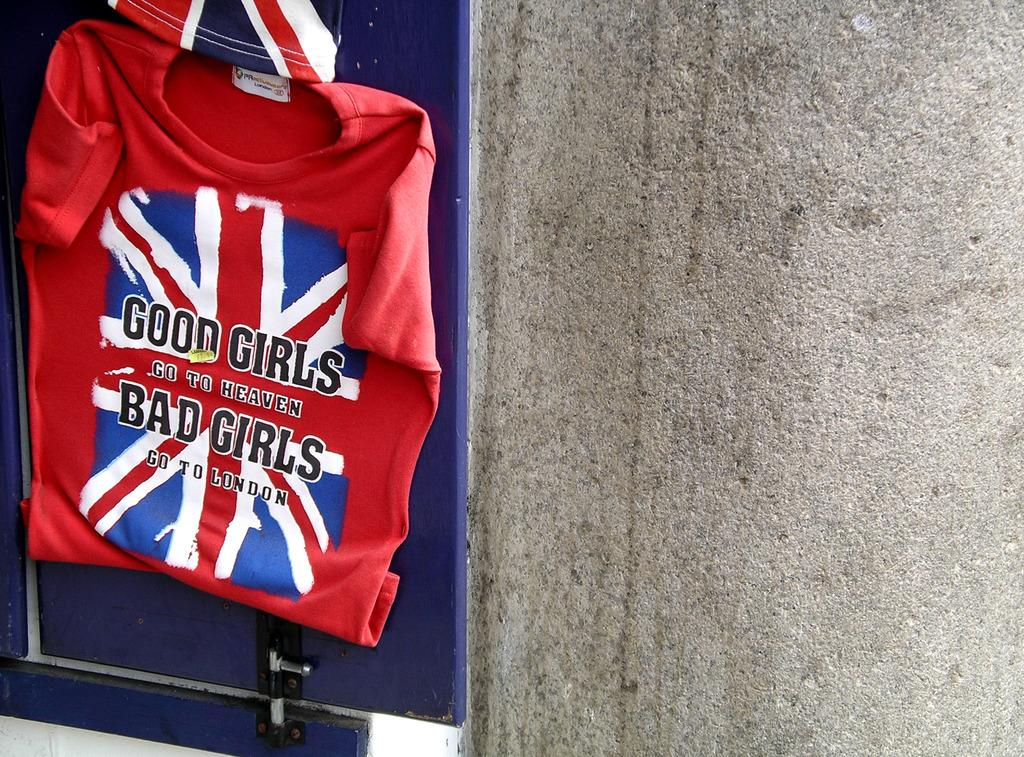Provide a one-sentence caption for the provided image. A shirt that says "Good girls go to heaven, bad girls go to London" hangs on a wall. 